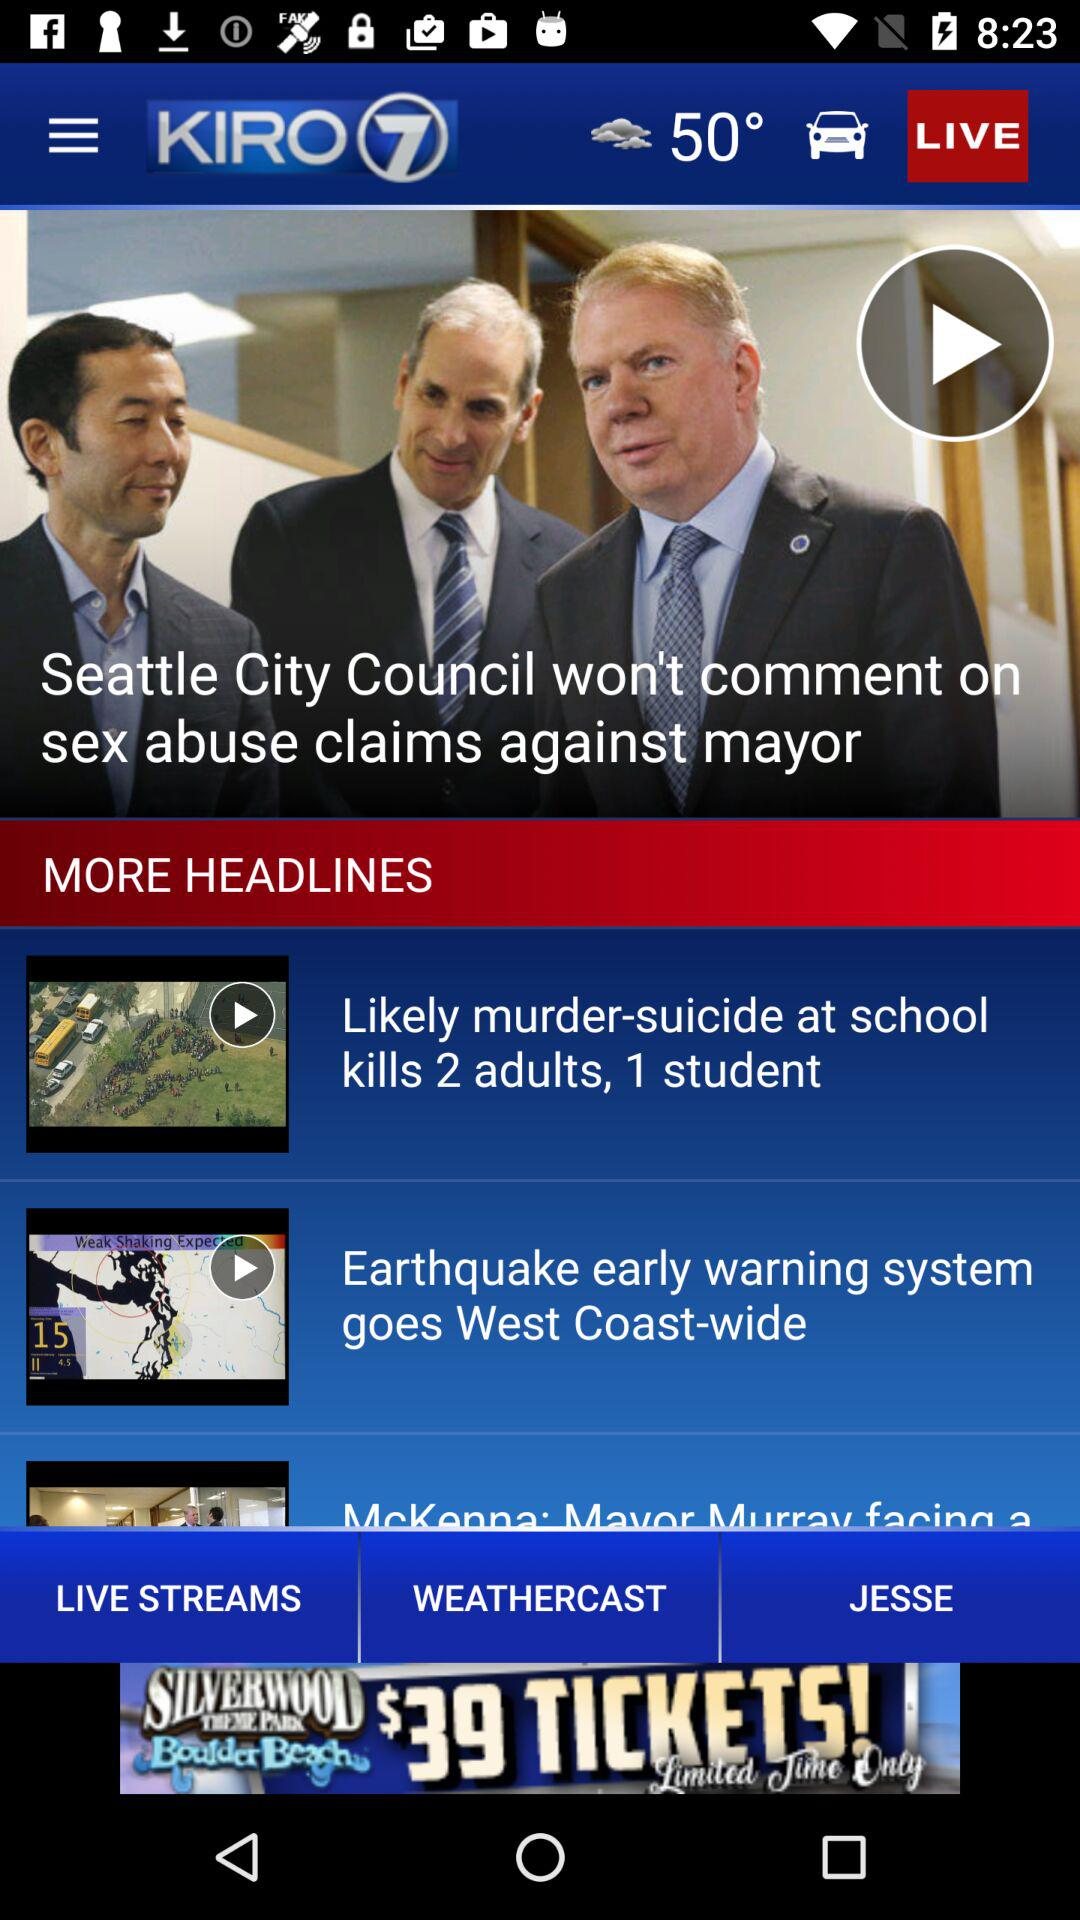What is the temperature shown on the screen? The temperature shown on the screen is 50°. 